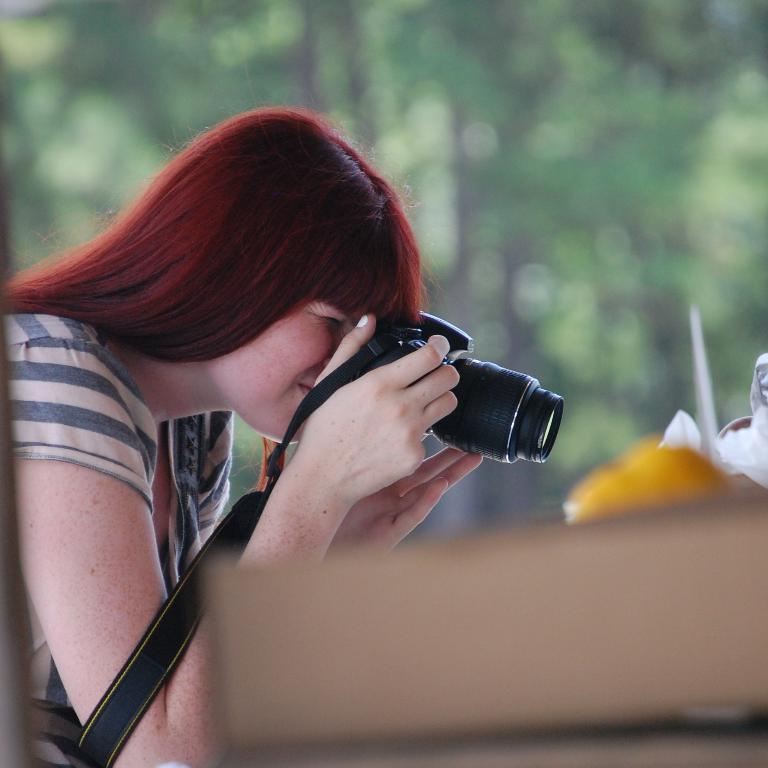Who is the main subject in the image? There is a woman in the image. Where is the woman located in the image? The woman is on the left side of the image. What is the woman doing in the image? The woman is holding a camera and clicking pictures. What can be seen in the background of the image? There are trees in the background of the image. What is present on the right side of the image? There are clothes on the right side of the image. What time is displayed on the clock in the image? There is no clock present in the image. What type of letter is the woman holding in the image? There is no letter present in the image; the woman is holding a camera. 